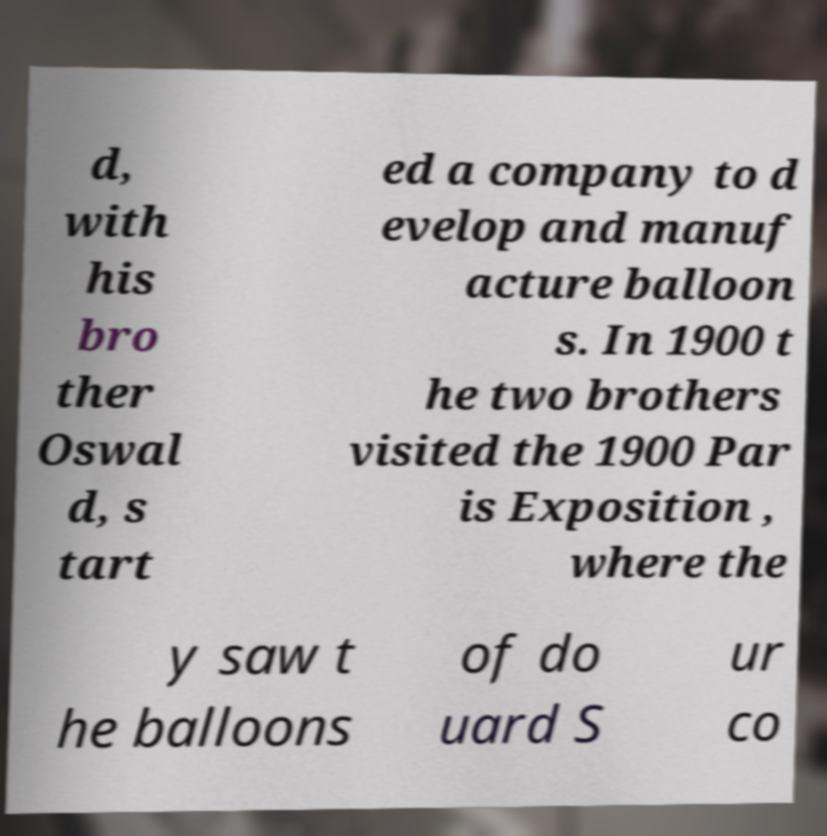Please identify and transcribe the text found in this image. d, with his bro ther Oswal d, s tart ed a company to d evelop and manuf acture balloon s. In 1900 t he two brothers visited the 1900 Par is Exposition , where the y saw t he balloons of do uard S ur co 